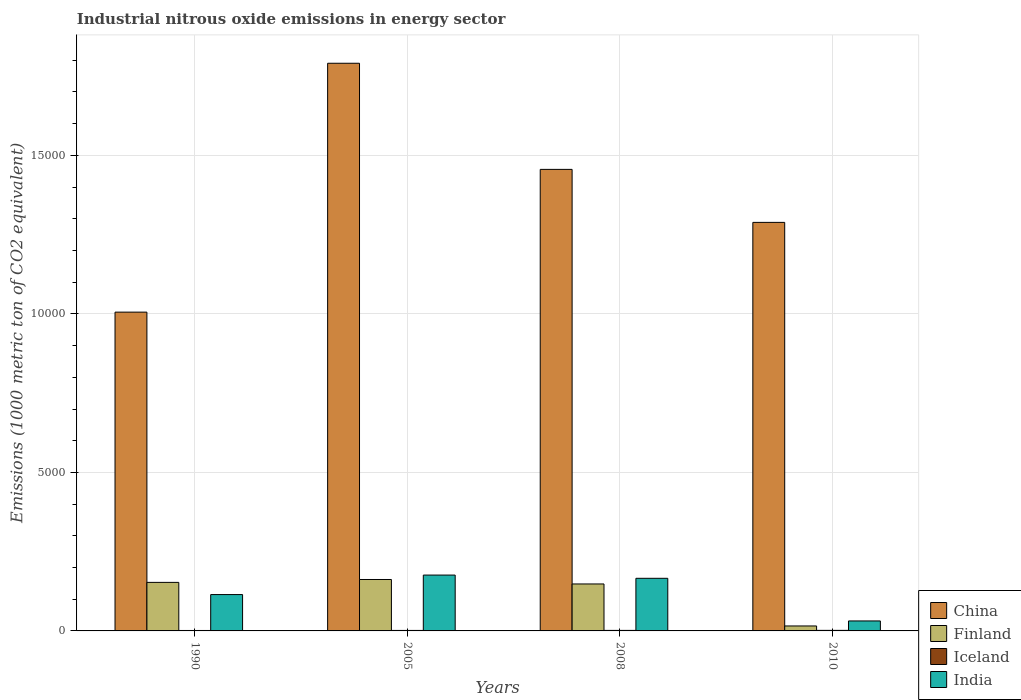How many groups of bars are there?
Offer a terse response. 4. Are the number of bars per tick equal to the number of legend labels?
Provide a short and direct response. Yes. Are the number of bars on each tick of the X-axis equal?
Your answer should be compact. Yes. How many bars are there on the 2nd tick from the right?
Your answer should be very brief. 4. What is the label of the 1st group of bars from the left?
Your answer should be compact. 1990. Across all years, what is the maximum amount of industrial nitrous oxide emitted in Finland?
Give a very brief answer. 1622.4. Across all years, what is the minimum amount of industrial nitrous oxide emitted in Finland?
Keep it short and to the point. 156.3. In which year was the amount of industrial nitrous oxide emitted in Finland maximum?
Make the answer very short. 2005. What is the total amount of industrial nitrous oxide emitted in Iceland in the graph?
Your answer should be very brief. 63.7. What is the difference between the amount of industrial nitrous oxide emitted in China in 1990 and that in 2005?
Your answer should be very brief. -7850.3. What is the difference between the amount of industrial nitrous oxide emitted in Finland in 2010 and the amount of industrial nitrous oxide emitted in Iceland in 1990?
Make the answer very short. 142.3. What is the average amount of industrial nitrous oxide emitted in Finland per year?
Provide a succinct answer. 1197.78. In the year 2010, what is the difference between the amount of industrial nitrous oxide emitted in Iceland and amount of industrial nitrous oxide emitted in China?
Your response must be concise. -1.29e+04. In how many years, is the amount of industrial nitrous oxide emitted in Finland greater than 12000 1000 metric ton?
Ensure brevity in your answer.  0. What is the ratio of the amount of industrial nitrous oxide emitted in China in 2005 to that in 2010?
Offer a terse response. 1.39. What is the difference between the highest and the second highest amount of industrial nitrous oxide emitted in China?
Offer a terse response. 3347.5. What is the difference between the highest and the lowest amount of industrial nitrous oxide emitted in China?
Keep it short and to the point. 7850.3. Is it the case that in every year, the sum of the amount of industrial nitrous oxide emitted in India and amount of industrial nitrous oxide emitted in Finland is greater than the sum of amount of industrial nitrous oxide emitted in China and amount of industrial nitrous oxide emitted in Iceland?
Give a very brief answer. No. Is it the case that in every year, the sum of the amount of industrial nitrous oxide emitted in Finland and amount of industrial nitrous oxide emitted in China is greater than the amount of industrial nitrous oxide emitted in Iceland?
Your answer should be compact. Yes. How many bars are there?
Give a very brief answer. 16. Are the values on the major ticks of Y-axis written in scientific E-notation?
Make the answer very short. No. Does the graph contain grids?
Provide a succinct answer. Yes. How are the legend labels stacked?
Provide a succinct answer. Vertical. What is the title of the graph?
Make the answer very short. Industrial nitrous oxide emissions in energy sector. What is the label or title of the X-axis?
Ensure brevity in your answer.  Years. What is the label or title of the Y-axis?
Your answer should be very brief. Emissions (1000 metric ton of CO2 equivalent). What is the Emissions (1000 metric ton of CO2 equivalent) in China in 1990?
Offer a terse response. 1.01e+04. What is the Emissions (1000 metric ton of CO2 equivalent) in Finland in 1990?
Provide a short and direct response. 1530.9. What is the Emissions (1000 metric ton of CO2 equivalent) of Iceland in 1990?
Offer a terse response. 14. What is the Emissions (1000 metric ton of CO2 equivalent) of India in 1990?
Provide a short and direct response. 1146.7. What is the Emissions (1000 metric ton of CO2 equivalent) of China in 2005?
Your answer should be compact. 1.79e+04. What is the Emissions (1000 metric ton of CO2 equivalent) of Finland in 2005?
Your answer should be very brief. 1622.4. What is the Emissions (1000 metric ton of CO2 equivalent) of India in 2005?
Provide a short and direct response. 1761.9. What is the Emissions (1000 metric ton of CO2 equivalent) of China in 2008?
Make the answer very short. 1.46e+04. What is the Emissions (1000 metric ton of CO2 equivalent) of Finland in 2008?
Your answer should be compact. 1481.5. What is the Emissions (1000 metric ton of CO2 equivalent) in India in 2008?
Keep it short and to the point. 1659.8. What is the Emissions (1000 metric ton of CO2 equivalent) in China in 2010?
Offer a terse response. 1.29e+04. What is the Emissions (1000 metric ton of CO2 equivalent) of Finland in 2010?
Your response must be concise. 156.3. What is the Emissions (1000 metric ton of CO2 equivalent) in India in 2010?
Give a very brief answer. 314.9. Across all years, what is the maximum Emissions (1000 metric ton of CO2 equivalent) in China?
Give a very brief answer. 1.79e+04. Across all years, what is the maximum Emissions (1000 metric ton of CO2 equivalent) in Finland?
Ensure brevity in your answer.  1622.4. Across all years, what is the maximum Emissions (1000 metric ton of CO2 equivalent) in Iceland?
Make the answer very short. 17.7. Across all years, what is the maximum Emissions (1000 metric ton of CO2 equivalent) of India?
Your answer should be compact. 1761.9. Across all years, what is the minimum Emissions (1000 metric ton of CO2 equivalent) in China?
Your response must be concise. 1.01e+04. Across all years, what is the minimum Emissions (1000 metric ton of CO2 equivalent) in Finland?
Offer a terse response. 156.3. Across all years, what is the minimum Emissions (1000 metric ton of CO2 equivalent) of India?
Offer a terse response. 314.9. What is the total Emissions (1000 metric ton of CO2 equivalent) in China in the graph?
Provide a short and direct response. 5.54e+04. What is the total Emissions (1000 metric ton of CO2 equivalent) in Finland in the graph?
Ensure brevity in your answer.  4791.1. What is the total Emissions (1000 metric ton of CO2 equivalent) of Iceland in the graph?
Your response must be concise. 63.7. What is the total Emissions (1000 metric ton of CO2 equivalent) of India in the graph?
Give a very brief answer. 4883.3. What is the difference between the Emissions (1000 metric ton of CO2 equivalent) of China in 1990 and that in 2005?
Provide a short and direct response. -7850.3. What is the difference between the Emissions (1000 metric ton of CO2 equivalent) in Finland in 1990 and that in 2005?
Provide a succinct answer. -91.5. What is the difference between the Emissions (1000 metric ton of CO2 equivalent) in India in 1990 and that in 2005?
Your answer should be compact. -615.2. What is the difference between the Emissions (1000 metric ton of CO2 equivalent) of China in 1990 and that in 2008?
Keep it short and to the point. -4502.8. What is the difference between the Emissions (1000 metric ton of CO2 equivalent) in Finland in 1990 and that in 2008?
Your response must be concise. 49.4. What is the difference between the Emissions (1000 metric ton of CO2 equivalent) in India in 1990 and that in 2008?
Provide a short and direct response. -513.1. What is the difference between the Emissions (1000 metric ton of CO2 equivalent) in China in 1990 and that in 2010?
Make the answer very short. -2830.9. What is the difference between the Emissions (1000 metric ton of CO2 equivalent) of Finland in 1990 and that in 2010?
Give a very brief answer. 1374.6. What is the difference between the Emissions (1000 metric ton of CO2 equivalent) in Iceland in 1990 and that in 2010?
Provide a succinct answer. -3.7. What is the difference between the Emissions (1000 metric ton of CO2 equivalent) in India in 1990 and that in 2010?
Offer a very short reply. 831.8. What is the difference between the Emissions (1000 metric ton of CO2 equivalent) of China in 2005 and that in 2008?
Provide a short and direct response. 3347.5. What is the difference between the Emissions (1000 metric ton of CO2 equivalent) in Finland in 2005 and that in 2008?
Give a very brief answer. 140.9. What is the difference between the Emissions (1000 metric ton of CO2 equivalent) of India in 2005 and that in 2008?
Make the answer very short. 102.1. What is the difference between the Emissions (1000 metric ton of CO2 equivalent) of China in 2005 and that in 2010?
Give a very brief answer. 5019.4. What is the difference between the Emissions (1000 metric ton of CO2 equivalent) of Finland in 2005 and that in 2010?
Ensure brevity in your answer.  1466.1. What is the difference between the Emissions (1000 metric ton of CO2 equivalent) of Iceland in 2005 and that in 2010?
Give a very brief answer. -2.4. What is the difference between the Emissions (1000 metric ton of CO2 equivalent) of India in 2005 and that in 2010?
Your answer should be compact. 1447. What is the difference between the Emissions (1000 metric ton of CO2 equivalent) of China in 2008 and that in 2010?
Make the answer very short. 1671.9. What is the difference between the Emissions (1000 metric ton of CO2 equivalent) in Finland in 2008 and that in 2010?
Make the answer very short. 1325.2. What is the difference between the Emissions (1000 metric ton of CO2 equivalent) in India in 2008 and that in 2010?
Keep it short and to the point. 1344.9. What is the difference between the Emissions (1000 metric ton of CO2 equivalent) in China in 1990 and the Emissions (1000 metric ton of CO2 equivalent) in Finland in 2005?
Make the answer very short. 8433.7. What is the difference between the Emissions (1000 metric ton of CO2 equivalent) in China in 1990 and the Emissions (1000 metric ton of CO2 equivalent) in Iceland in 2005?
Offer a terse response. 1.00e+04. What is the difference between the Emissions (1000 metric ton of CO2 equivalent) in China in 1990 and the Emissions (1000 metric ton of CO2 equivalent) in India in 2005?
Provide a short and direct response. 8294.2. What is the difference between the Emissions (1000 metric ton of CO2 equivalent) of Finland in 1990 and the Emissions (1000 metric ton of CO2 equivalent) of Iceland in 2005?
Your answer should be compact. 1515.6. What is the difference between the Emissions (1000 metric ton of CO2 equivalent) in Finland in 1990 and the Emissions (1000 metric ton of CO2 equivalent) in India in 2005?
Make the answer very short. -231. What is the difference between the Emissions (1000 metric ton of CO2 equivalent) in Iceland in 1990 and the Emissions (1000 metric ton of CO2 equivalent) in India in 2005?
Make the answer very short. -1747.9. What is the difference between the Emissions (1000 metric ton of CO2 equivalent) in China in 1990 and the Emissions (1000 metric ton of CO2 equivalent) in Finland in 2008?
Your answer should be compact. 8574.6. What is the difference between the Emissions (1000 metric ton of CO2 equivalent) in China in 1990 and the Emissions (1000 metric ton of CO2 equivalent) in Iceland in 2008?
Provide a short and direct response. 1.00e+04. What is the difference between the Emissions (1000 metric ton of CO2 equivalent) of China in 1990 and the Emissions (1000 metric ton of CO2 equivalent) of India in 2008?
Your answer should be compact. 8396.3. What is the difference between the Emissions (1000 metric ton of CO2 equivalent) of Finland in 1990 and the Emissions (1000 metric ton of CO2 equivalent) of Iceland in 2008?
Make the answer very short. 1514.2. What is the difference between the Emissions (1000 metric ton of CO2 equivalent) in Finland in 1990 and the Emissions (1000 metric ton of CO2 equivalent) in India in 2008?
Offer a very short reply. -128.9. What is the difference between the Emissions (1000 metric ton of CO2 equivalent) of Iceland in 1990 and the Emissions (1000 metric ton of CO2 equivalent) of India in 2008?
Your response must be concise. -1645.8. What is the difference between the Emissions (1000 metric ton of CO2 equivalent) of China in 1990 and the Emissions (1000 metric ton of CO2 equivalent) of Finland in 2010?
Your answer should be compact. 9899.8. What is the difference between the Emissions (1000 metric ton of CO2 equivalent) in China in 1990 and the Emissions (1000 metric ton of CO2 equivalent) in Iceland in 2010?
Make the answer very short. 1.00e+04. What is the difference between the Emissions (1000 metric ton of CO2 equivalent) of China in 1990 and the Emissions (1000 metric ton of CO2 equivalent) of India in 2010?
Your response must be concise. 9741.2. What is the difference between the Emissions (1000 metric ton of CO2 equivalent) in Finland in 1990 and the Emissions (1000 metric ton of CO2 equivalent) in Iceland in 2010?
Offer a terse response. 1513.2. What is the difference between the Emissions (1000 metric ton of CO2 equivalent) of Finland in 1990 and the Emissions (1000 metric ton of CO2 equivalent) of India in 2010?
Make the answer very short. 1216. What is the difference between the Emissions (1000 metric ton of CO2 equivalent) in Iceland in 1990 and the Emissions (1000 metric ton of CO2 equivalent) in India in 2010?
Offer a very short reply. -300.9. What is the difference between the Emissions (1000 metric ton of CO2 equivalent) of China in 2005 and the Emissions (1000 metric ton of CO2 equivalent) of Finland in 2008?
Offer a terse response. 1.64e+04. What is the difference between the Emissions (1000 metric ton of CO2 equivalent) in China in 2005 and the Emissions (1000 metric ton of CO2 equivalent) in Iceland in 2008?
Offer a very short reply. 1.79e+04. What is the difference between the Emissions (1000 metric ton of CO2 equivalent) of China in 2005 and the Emissions (1000 metric ton of CO2 equivalent) of India in 2008?
Make the answer very short. 1.62e+04. What is the difference between the Emissions (1000 metric ton of CO2 equivalent) in Finland in 2005 and the Emissions (1000 metric ton of CO2 equivalent) in Iceland in 2008?
Offer a very short reply. 1605.7. What is the difference between the Emissions (1000 metric ton of CO2 equivalent) of Finland in 2005 and the Emissions (1000 metric ton of CO2 equivalent) of India in 2008?
Keep it short and to the point. -37.4. What is the difference between the Emissions (1000 metric ton of CO2 equivalent) in Iceland in 2005 and the Emissions (1000 metric ton of CO2 equivalent) in India in 2008?
Provide a succinct answer. -1644.5. What is the difference between the Emissions (1000 metric ton of CO2 equivalent) in China in 2005 and the Emissions (1000 metric ton of CO2 equivalent) in Finland in 2010?
Your response must be concise. 1.78e+04. What is the difference between the Emissions (1000 metric ton of CO2 equivalent) in China in 2005 and the Emissions (1000 metric ton of CO2 equivalent) in Iceland in 2010?
Give a very brief answer. 1.79e+04. What is the difference between the Emissions (1000 metric ton of CO2 equivalent) of China in 2005 and the Emissions (1000 metric ton of CO2 equivalent) of India in 2010?
Your response must be concise. 1.76e+04. What is the difference between the Emissions (1000 metric ton of CO2 equivalent) of Finland in 2005 and the Emissions (1000 metric ton of CO2 equivalent) of Iceland in 2010?
Your response must be concise. 1604.7. What is the difference between the Emissions (1000 metric ton of CO2 equivalent) of Finland in 2005 and the Emissions (1000 metric ton of CO2 equivalent) of India in 2010?
Give a very brief answer. 1307.5. What is the difference between the Emissions (1000 metric ton of CO2 equivalent) in Iceland in 2005 and the Emissions (1000 metric ton of CO2 equivalent) in India in 2010?
Keep it short and to the point. -299.6. What is the difference between the Emissions (1000 metric ton of CO2 equivalent) of China in 2008 and the Emissions (1000 metric ton of CO2 equivalent) of Finland in 2010?
Your response must be concise. 1.44e+04. What is the difference between the Emissions (1000 metric ton of CO2 equivalent) in China in 2008 and the Emissions (1000 metric ton of CO2 equivalent) in Iceland in 2010?
Ensure brevity in your answer.  1.45e+04. What is the difference between the Emissions (1000 metric ton of CO2 equivalent) of China in 2008 and the Emissions (1000 metric ton of CO2 equivalent) of India in 2010?
Keep it short and to the point. 1.42e+04. What is the difference between the Emissions (1000 metric ton of CO2 equivalent) in Finland in 2008 and the Emissions (1000 metric ton of CO2 equivalent) in Iceland in 2010?
Ensure brevity in your answer.  1463.8. What is the difference between the Emissions (1000 metric ton of CO2 equivalent) of Finland in 2008 and the Emissions (1000 metric ton of CO2 equivalent) of India in 2010?
Offer a terse response. 1166.6. What is the difference between the Emissions (1000 metric ton of CO2 equivalent) in Iceland in 2008 and the Emissions (1000 metric ton of CO2 equivalent) in India in 2010?
Offer a terse response. -298.2. What is the average Emissions (1000 metric ton of CO2 equivalent) of China per year?
Ensure brevity in your answer.  1.39e+04. What is the average Emissions (1000 metric ton of CO2 equivalent) in Finland per year?
Keep it short and to the point. 1197.78. What is the average Emissions (1000 metric ton of CO2 equivalent) of Iceland per year?
Your answer should be compact. 15.93. What is the average Emissions (1000 metric ton of CO2 equivalent) of India per year?
Give a very brief answer. 1220.83. In the year 1990, what is the difference between the Emissions (1000 metric ton of CO2 equivalent) in China and Emissions (1000 metric ton of CO2 equivalent) in Finland?
Offer a terse response. 8525.2. In the year 1990, what is the difference between the Emissions (1000 metric ton of CO2 equivalent) of China and Emissions (1000 metric ton of CO2 equivalent) of Iceland?
Make the answer very short. 1.00e+04. In the year 1990, what is the difference between the Emissions (1000 metric ton of CO2 equivalent) in China and Emissions (1000 metric ton of CO2 equivalent) in India?
Offer a very short reply. 8909.4. In the year 1990, what is the difference between the Emissions (1000 metric ton of CO2 equivalent) in Finland and Emissions (1000 metric ton of CO2 equivalent) in Iceland?
Keep it short and to the point. 1516.9. In the year 1990, what is the difference between the Emissions (1000 metric ton of CO2 equivalent) of Finland and Emissions (1000 metric ton of CO2 equivalent) of India?
Provide a succinct answer. 384.2. In the year 1990, what is the difference between the Emissions (1000 metric ton of CO2 equivalent) in Iceland and Emissions (1000 metric ton of CO2 equivalent) in India?
Ensure brevity in your answer.  -1132.7. In the year 2005, what is the difference between the Emissions (1000 metric ton of CO2 equivalent) of China and Emissions (1000 metric ton of CO2 equivalent) of Finland?
Give a very brief answer. 1.63e+04. In the year 2005, what is the difference between the Emissions (1000 metric ton of CO2 equivalent) of China and Emissions (1000 metric ton of CO2 equivalent) of Iceland?
Your answer should be very brief. 1.79e+04. In the year 2005, what is the difference between the Emissions (1000 metric ton of CO2 equivalent) in China and Emissions (1000 metric ton of CO2 equivalent) in India?
Keep it short and to the point. 1.61e+04. In the year 2005, what is the difference between the Emissions (1000 metric ton of CO2 equivalent) in Finland and Emissions (1000 metric ton of CO2 equivalent) in Iceland?
Offer a terse response. 1607.1. In the year 2005, what is the difference between the Emissions (1000 metric ton of CO2 equivalent) in Finland and Emissions (1000 metric ton of CO2 equivalent) in India?
Give a very brief answer. -139.5. In the year 2005, what is the difference between the Emissions (1000 metric ton of CO2 equivalent) in Iceland and Emissions (1000 metric ton of CO2 equivalent) in India?
Provide a short and direct response. -1746.6. In the year 2008, what is the difference between the Emissions (1000 metric ton of CO2 equivalent) of China and Emissions (1000 metric ton of CO2 equivalent) of Finland?
Your response must be concise. 1.31e+04. In the year 2008, what is the difference between the Emissions (1000 metric ton of CO2 equivalent) of China and Emissions (1000 metric ton of CO2 equivalent) of Iceland?
Your response must be concise. 1.45e+04. In the year 2008, what is the difference between the Emissions (1000 metric ton of CO2 equivalent) of China and Emissions (1000 metric ton of CO2 equivalent) of India?
Ensure brevity in your answer.  1.29e+04. In the year 2008, what is the difference between the Emissions (1000 metric ton of CO2 equivalent) of Finland and Emissions (1000 metric ton of CO2 equivalent) of Iceland?
Provide a short and direct response. 1464.8. In the year 2008, what is the difference between the Emissions (1000 metric ton of CO2 equivalent) in Finland and Emissions (1000 metric ton of CO2 equivalent) in India?
Offer a very short reply. -178.3. In the year 2008, what is the difference between the Emissions (1000 metric ton of CO2 equivalent) in Iceland and Emissions (1000 metric ton of CO2 equivalent) in India?
Make the answer very short. -1643.1. In the year 2010, what is the difference between the Emissions (1000 metric ton of CO2 equivalent) in China and Emissions (1000 metric ton of CO2 equivalent) in Finland?
Give a very brief answer. 1.27e+04. In the year 2010, what is the difference between the Emissions (1000 metric ton of CO2 equivalent) in China and Emissions (1000 metric ton of CO2 equivalent) in Iceland?
Your response must be concise. 1.29e+04. In the year 2010, what is the difference between the Emissions (1000 metric ton of CO2 equivalent) in China and Emissions (1000 metric ton of CO2 equivalent) in India?
Your response must be concise. 1.26e+04. In the year 2010, what is the difference between the Emissions (1000 metric ton of CO2 equivalent) of Finland and Emissions (1000 metric ton of CO2 equivalent) of Iceland?
Provide a succinct answer. 138.6. In the year 2010, what is the difference between the Emissions (1000 metric ton of CO2 equivalent) in Finland and Emissions (1000 metric ton of CO2 equivalent) in India?
Your answer should be compact. -158.6. In the year 2010, what is the difference between the Emissions (1000 metric ton of CO2 equivalent) of Iceland and Emissions (1000 metric ton of CO2 equivalent) of India?
Offer a terse response. -297.2. What is the ratio of the Emissions (1000 metric ton of CO2 equivalent) in China in 1990 to that in 2005?
Make the answer very short. 0.56. What is the ratio of the Emissions (1000 metric ton of CO2 equivalent) in Finland in 1990 to that in 2005?
Offer a terse response. 0.94. What is the ratio of the Emissions (1000 metric ton of CO2 equivalent) of Iceland in 1990 to that in 2005?
Offer a very short reply. 0.92. What is the ratio of the Emissions (1000 metric ton of CO2 equivalent) in India in 1990 to that in 2005?
Offer a very short reply. 0.65. What is the ratio of the Emissions (1000 metric ton of CO2 equivalent) in China in 1990 to that in 2008?
Provide a succinct answer. 0.69. What is the ratio of the Emissions (1000 metric ton of CO2 equivalent) of Iceland in 1990 to that in 2008?
Keep it short and to the point. 0.84. What is the ratio of the Emissions (1000 metric ton of CO2 equivalent) in India in 1990 to that in 2008?
Give a very brief answer. 0.69. What is the ratio of the Emissions (1000 metric ton of CO2 equivalent) in China in 1990 to that in 2010?
Your answer should be compact. 0.78. What is the ratio of the Emissions (1000 metric ton of CO2 equivalent) of Finland in 1990 to that in 2010?
Provide a short and direct response. 9.79. What is the ratio of the Emissions (1000 metric ton of CO2 equivalent) of Iceland in 1990 to that in 2010?
Ensure brevity in your answer.  0.79. What is the ratio of the Emissions (1000 metric ton of CO2 equivalent) in India in 1990 to that in 2010?
Provide a succinct answer. 3.64. What is the ratio of the Emissions (1000 metric ton of CO2 equivalent) in China in 2005 to that in 2008?
Offer a very short reply. 1.23. What is the ratio of the Emissions (1000 metric ton of CO2 equivalent) in Finland in 2005 to that in 2008?
Give a very brief answer. 1.1. What is the ratio of the Emissions (1000 metric ton of CO2 equivalent) of Iceland in 2005 to that in 2008?
Offer a terse response. 0.92. What is the ratio of the Emissions (1000 metric ton of CO2 equivalent) in India in 2005 to that in 2008?
Ensure brevity in your answer.  1.06. What is the ratio of the Emissions (1000 metric ton of CO2 equivalent) of China in 2005 to that in 2010?
Your response must be concise. 1.39. What is the ratio of the Emissions (1000 metric ton of CO2 equivalent) of Finland in 2005 to that in 2010?
Your answer should be very brief. 10.38. What is the ratio of the Emissions (1000 metric ton of CO2 equivalent) of Iceland in 2005 to that in 2010?
Give a very brief answer. 0.86. What is the ratio of the Emissions (1000 metric ton of CO2 equivalent) in India in 2005 to that in 2010?
Provide a short and direct response. 5.6. What is the ratio of the Emissions (1000 metric ton of CO2 equivalent) of China in 2008 to that in 2010?
Your answer should be compact. 1.13. What is the ratio of the Emissions (1000 metric ton of CO2 equivalent) in Finland in 2008 to that in 2010?
Ensure brevity in your answer.  9.48. What is the ratio of the Emissions (1000 metric ton of CO2 equivalent) in Iceland in 2008 to that in 2010?
Give a very brief answer. 0.94. What is the ratio of the Emissions (1000 metric ton of CO2 equivalent) in India in 2008 to that in 2010?
Keep it short and to the point. 5.27. What is the difference between the highest and the second highest Emissions (1000 metric ton of CO2 equivalent) of China?
Your response must be concise. 3347.5. What is the difference between the highest and the second highest Emissions (1000 metric ton of CO2 equivalent) in Finland?
Your answer should be compact. 91.5. What is the difference between the highest and the second highest Emissions (1000 metric ton of CO2 equivalent) in Iceland?
Offer a terse response. 1. What is the difference between the highest and the second highest Emissions (1000 metric ton of CO2 equivalent) in India?
Your response must be concise. 102.1. What is the difference between the highest and the lowest Emissions (1000 metric ton of CO2 equivalent) of China?
Your response must be concise. 7850.3. What is the difference between the highest and the lowest Emissions (1000 metric ton of CO2 equivalent) of Finland?
Ensure brevity in your answer.  1466.1. What is the difference between the highest and the lowest Emissions (1000 metric ton of CO2 equivalent) of India?
Ensure brevity in your answer.  1447. 